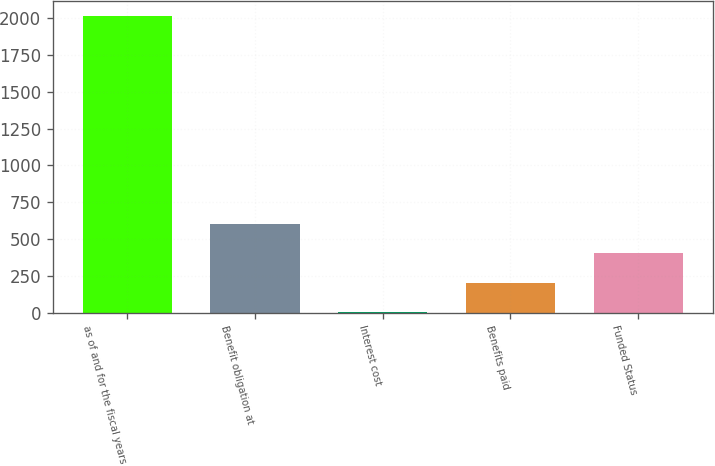Convert chart. <chart><loc_0><loc_0><loc_500><loc_500><bar_chart><fcel>as of and for the fiscal years<fcel>Benefit obligation at<fcel>Interest cost<fcel>Benefits paid<fcel>Funded Status<nl><fcel>2014<fcel>604.34<fcel>0.2<fcel>201.58<fcel>402.96<nl></chart> 